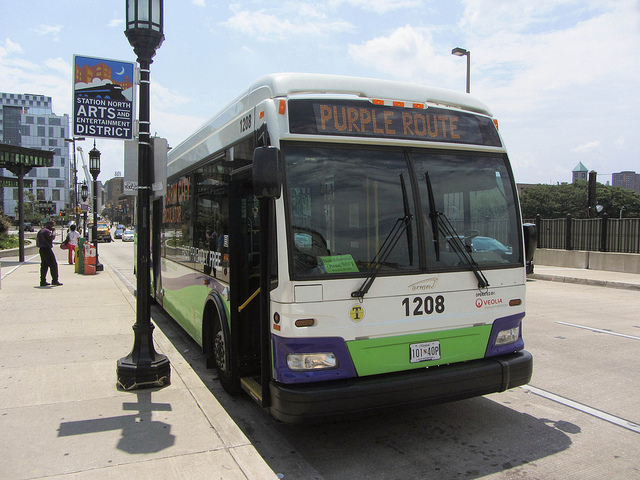Please transcribe the text in this image. PURPLE ROUTE 1208 ARTS DISTRICT ENTERTAINMENT AND NORTH STATION 101 